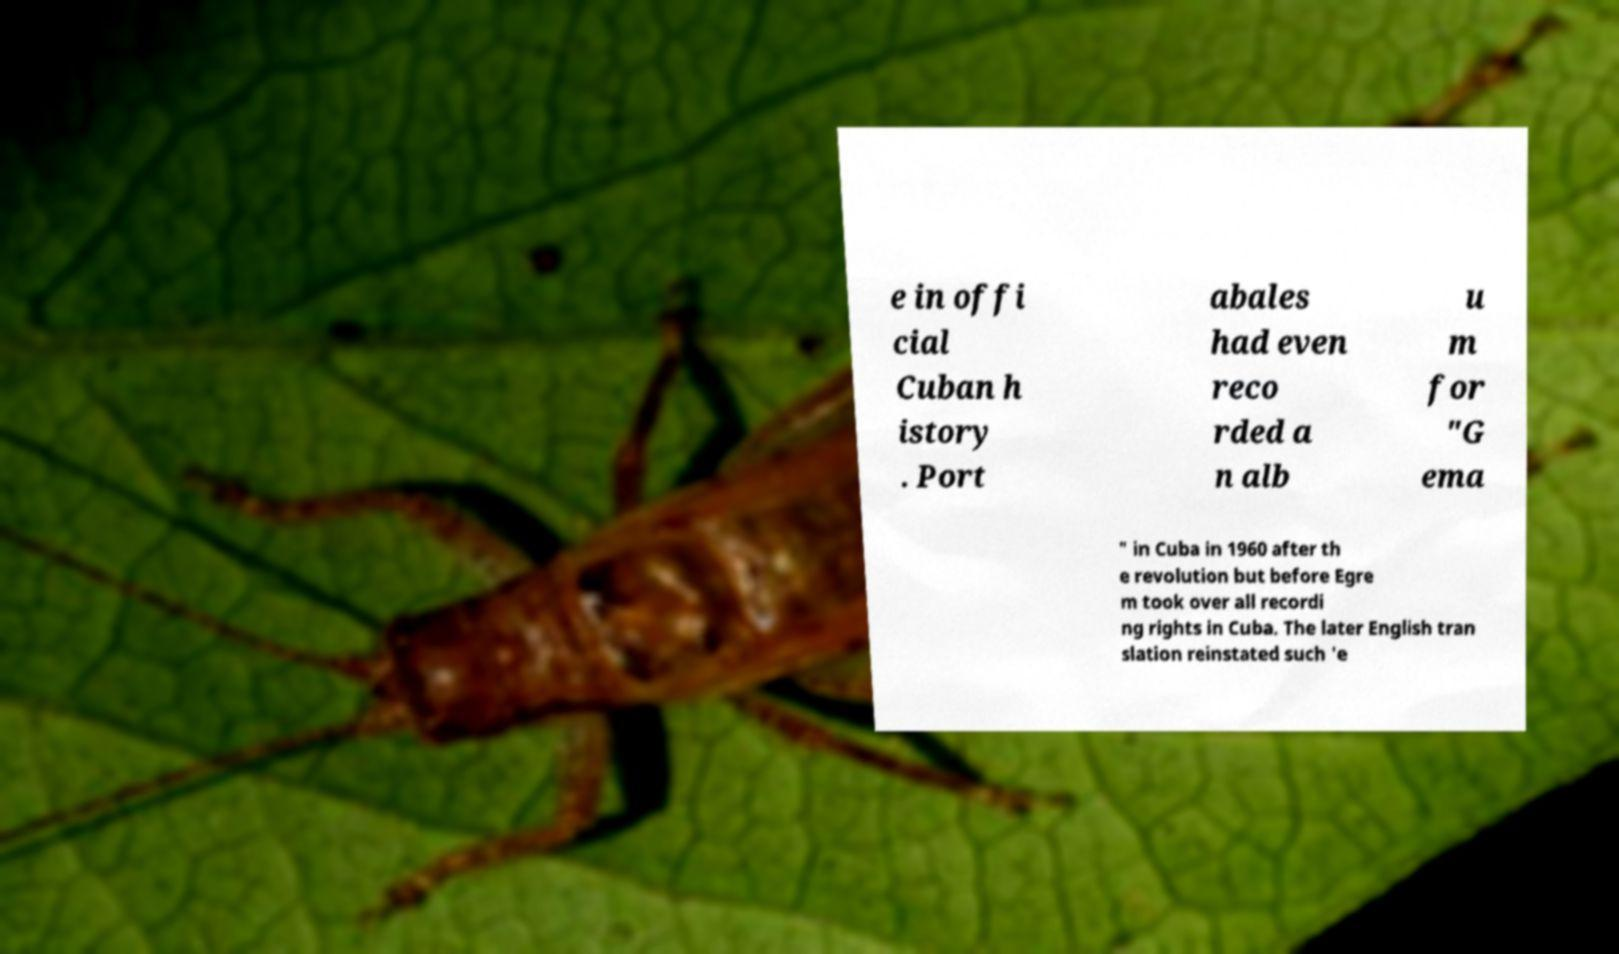For documentation purposes, I need the text within this image transcribed. Could you provide that? e in offi cial Cuban h istory . Port abales had even reco rded a n alb u m for "G ema " in Cuba in 1960 after th e revolution but before Egre m took over all recordi ng rights in Cuba. The later English tran slation reinstated such 'e 